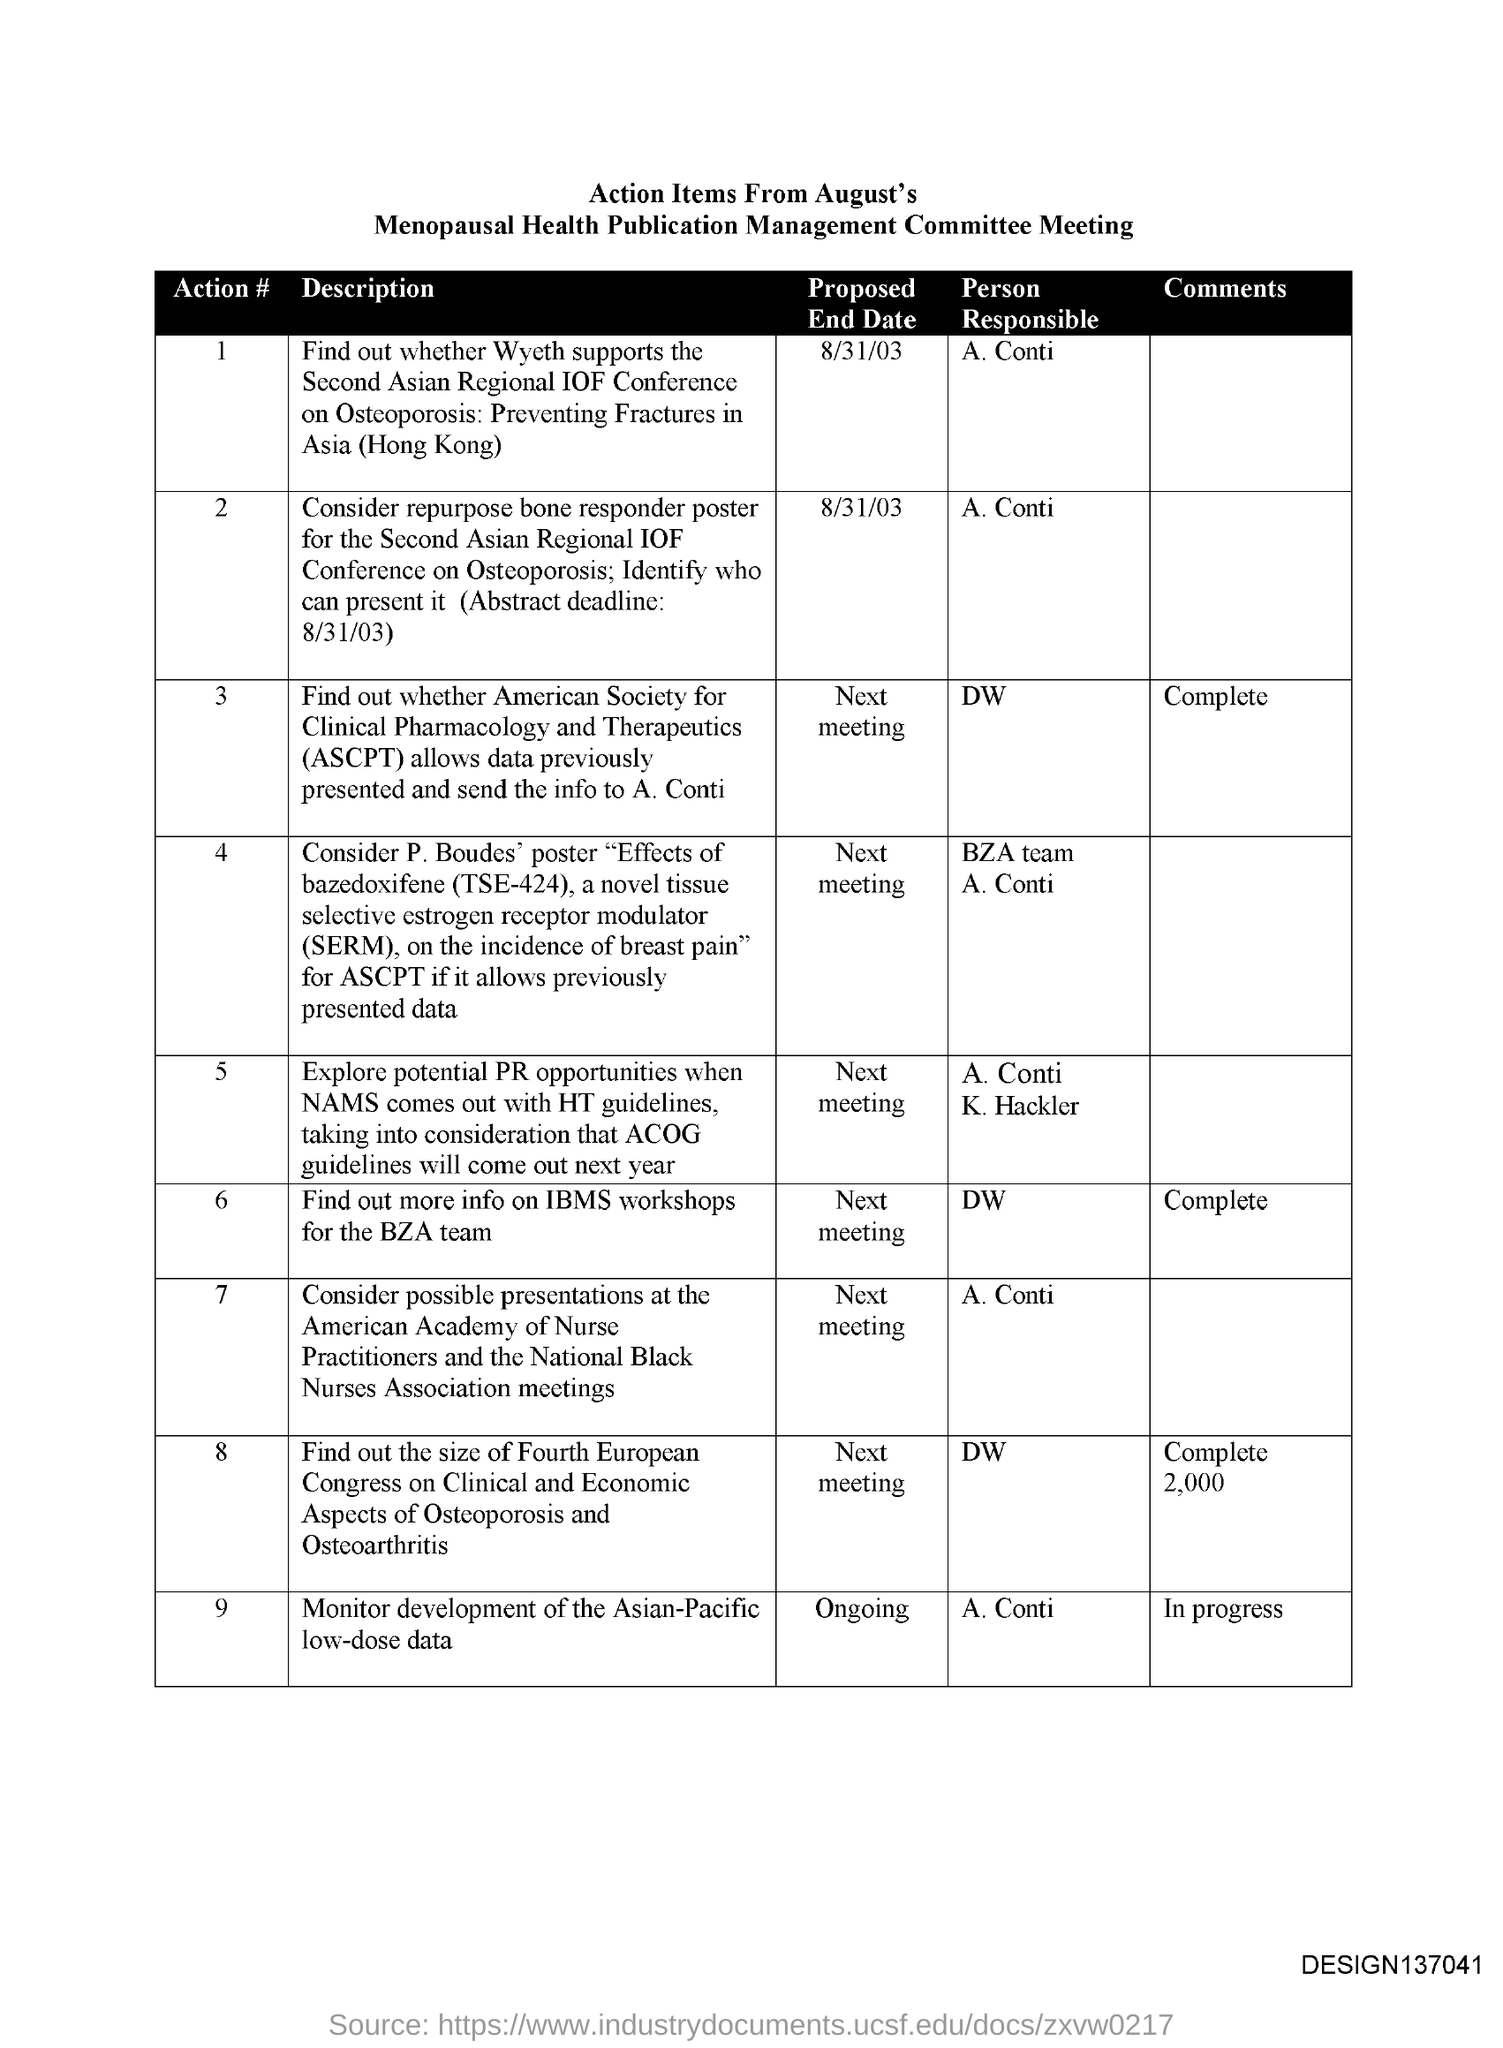Indicate a few pertinent items in this graphic. The responsibility for Action #2 belongs to Conti. The proposed end date of Action #1 is August 31, 2003. The bottom right corner of the page contains a code, designated as design137041... 